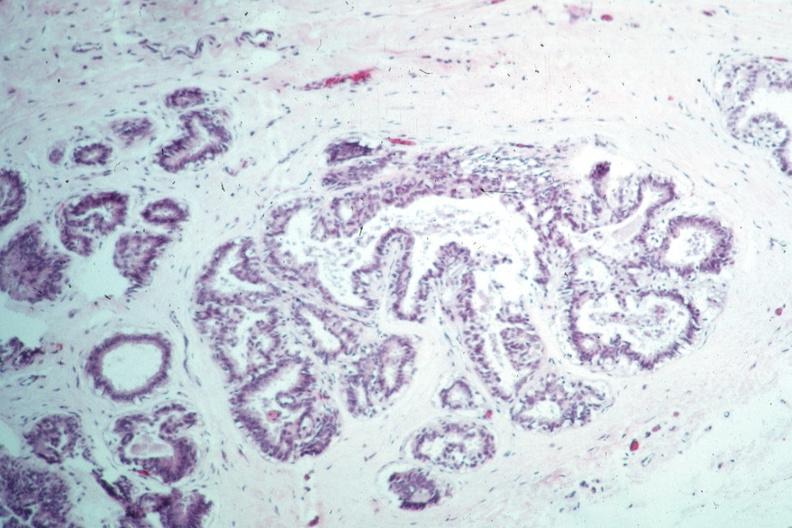s breast present?
Answer the question using a single word or phrase. Yes 